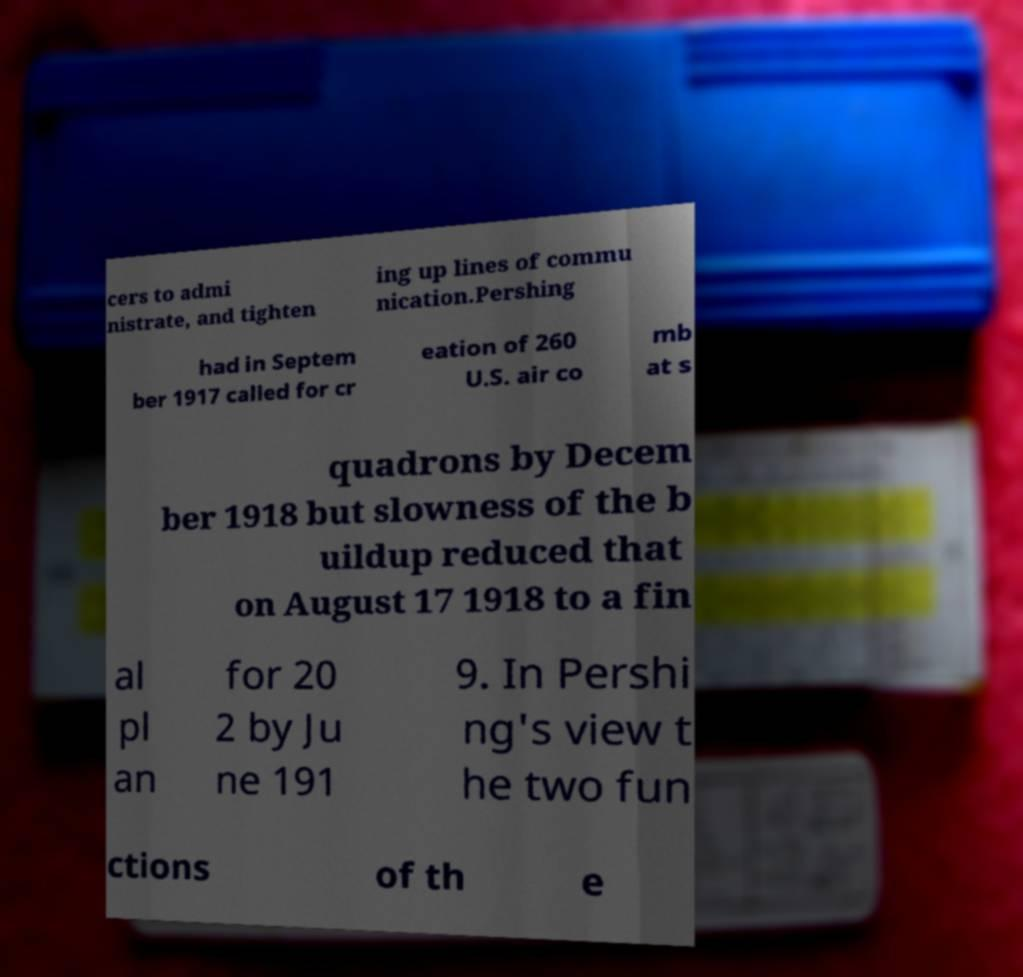I need the written content from this picture converted into text. Can you do that? cers to admi nistrate, and tighten ing up lines of commu nication.Pershing had in Septem ber 1917 called for cr eation of 260 U.S. air co mb at s quadrons by Decem ber 1918 but slowness of the b uildup reduced that on August 17 1918 to a fin al pl an for 20 2 by Ju ne 191 9. In Pershi ng's view t he two fun ctions of th e 